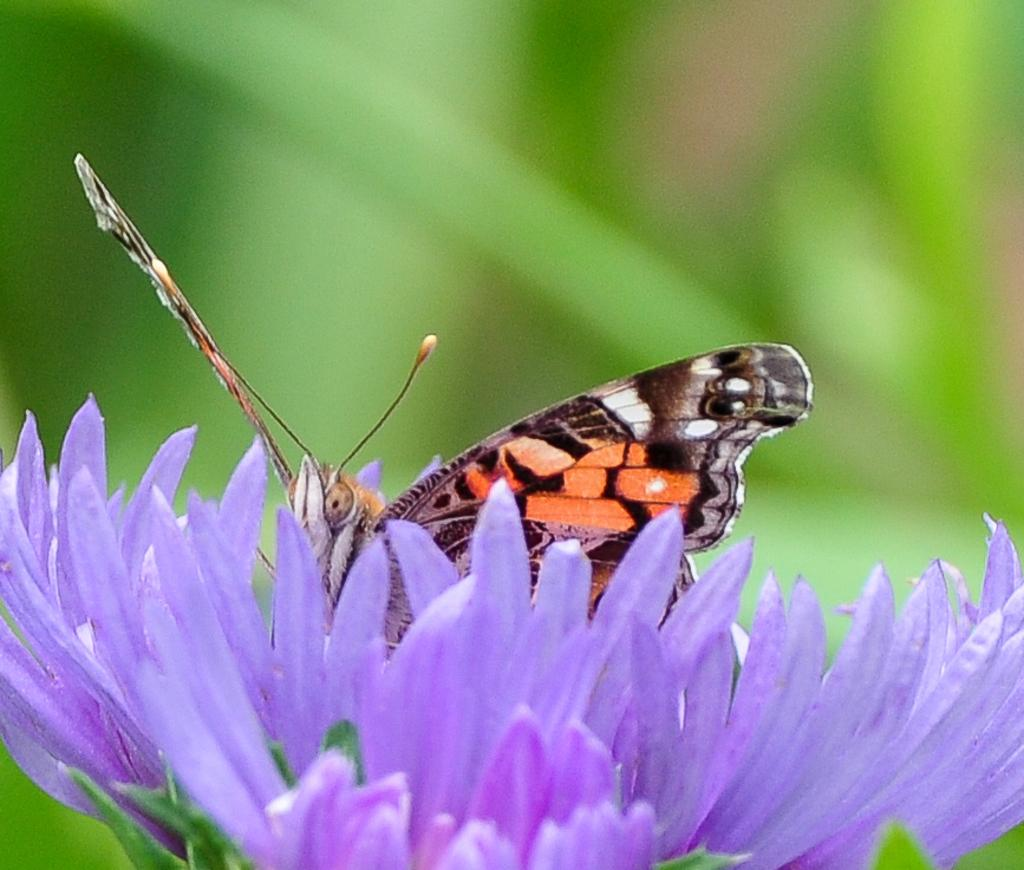What is the main subject of the image? There is a butterfly in the image. Where is the butterfly located? The butterfly is on a flower. Can you describe the background of the image? The background of the image is blurry. What type of shoe is the butterfly wearing in the image? There is no shoe present in the image, as butterflies do not wear shoes. 